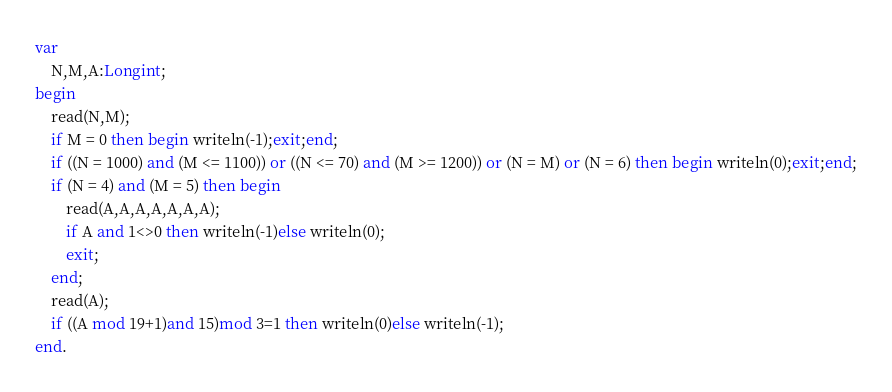<code> <loc_0><loc_0><loc_500><loc_500><_Pascal_>var
    N,M,A:Longint;
begin
    read(N,M);
    if M = 0 then begin writeln(-1);exit;end;
    if ((N = 1000) and (M <= 1100)) or ((N <= 70) and (M >= 1200)) or (N = M) or (N = 6) then begin writeln(0);exit;end;
    if (N = 4) and (M = 5) then begin
        read(A,A,A,A,A,A,A);
        if A and 1<>0 then writeln(-1)else writeln(0);
        exit;
    end;
    read(A);
    if ((A mod 19+1)and 15)mod 3=1 then writeln(0)else writeln(-1);
end.</code> 